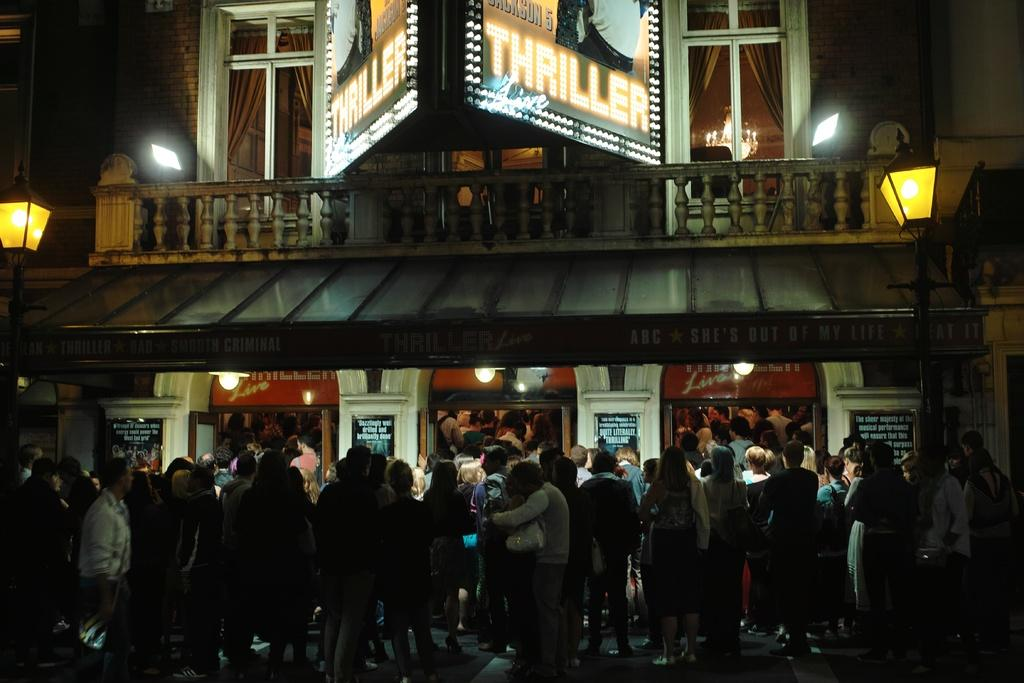<image>
Relay a brief, clear account of the picture shown. Members of the public queue outside a theatre showing Thriller Live. 